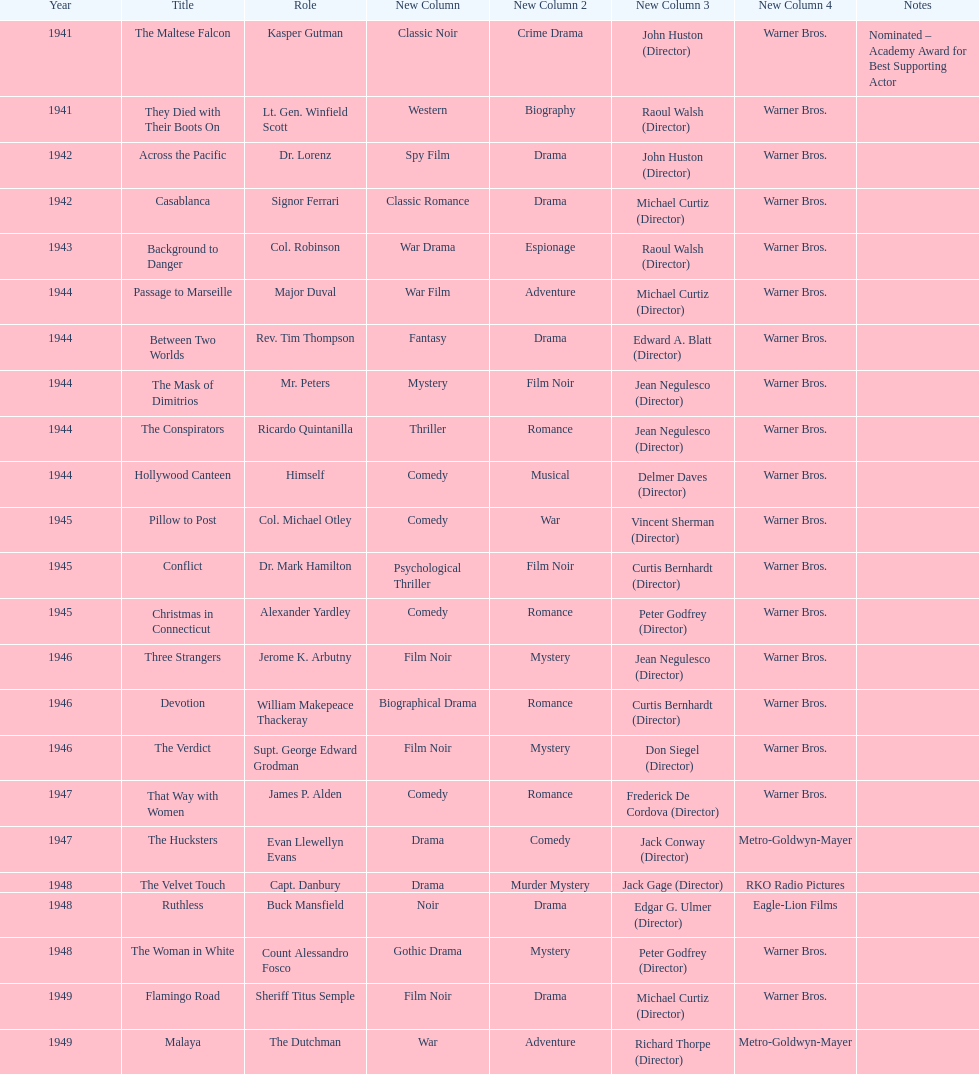What movies did greenstreet act for in 1946? Three Strangers, Devotion, The Verdict. 